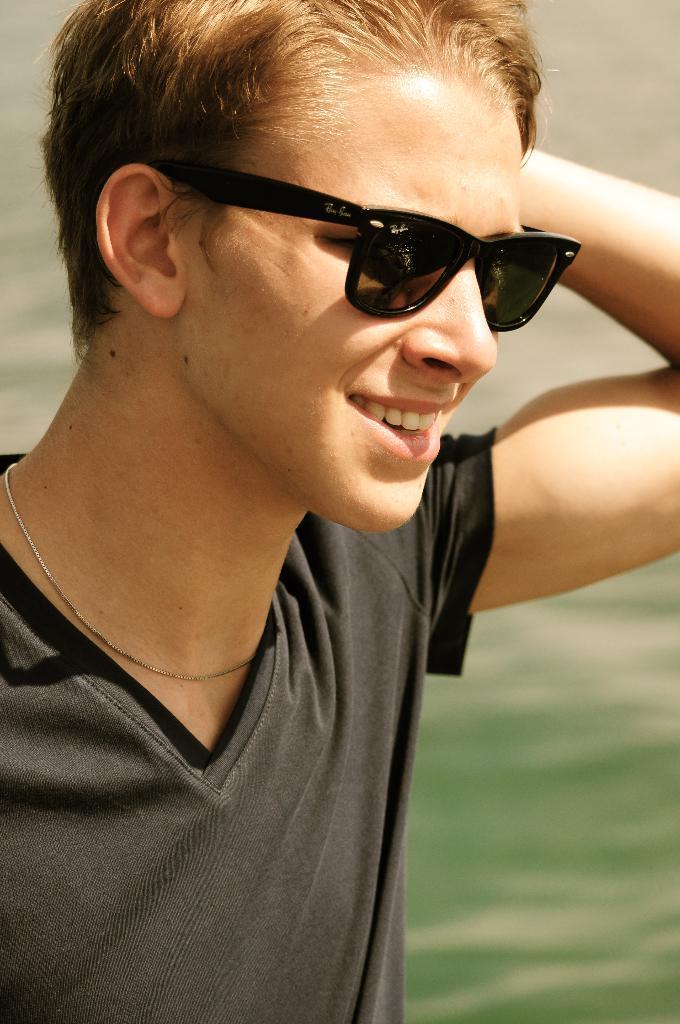Describe this image in one or two sentences. In this image we can see a person with goggles and a blurry background. 